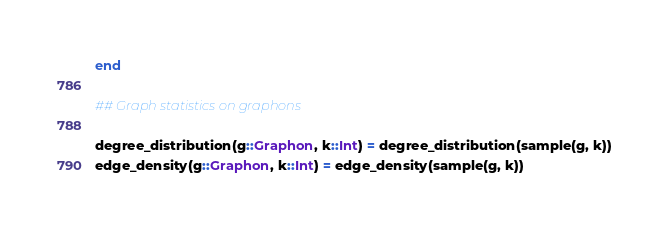<code> <loc_0><loc_0><loc_500><loc_500><_Julia_>end 

## Graph statistics on graphons

degree_distribution(g::Graphon, k::Int) = degree_distribution(sample(g, k))
edge_density(g::Graphon, k::Int) = edge_density(sample(g, k))</code> 